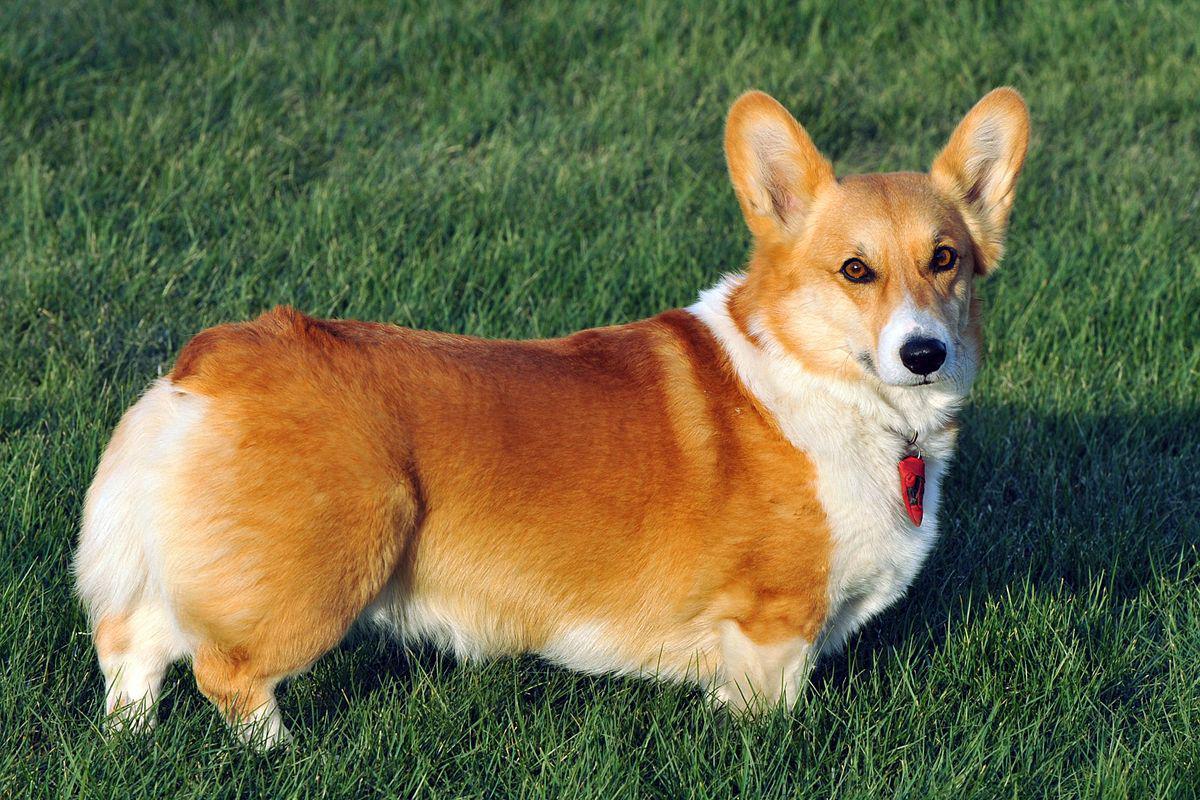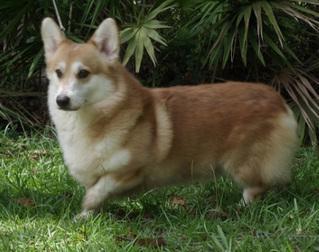The first image is the image on the left, the second image is the image on the right. Analyze the images presented: Is the assertion "Only one of the dogs has its mouth open." valid? Answer yes or no. No. The first image is the image on the left, the second image is the image on the right. Assess this claim about the two images: "There are two dogs in the left image.". Correct or not? Answer yes or no. No. 